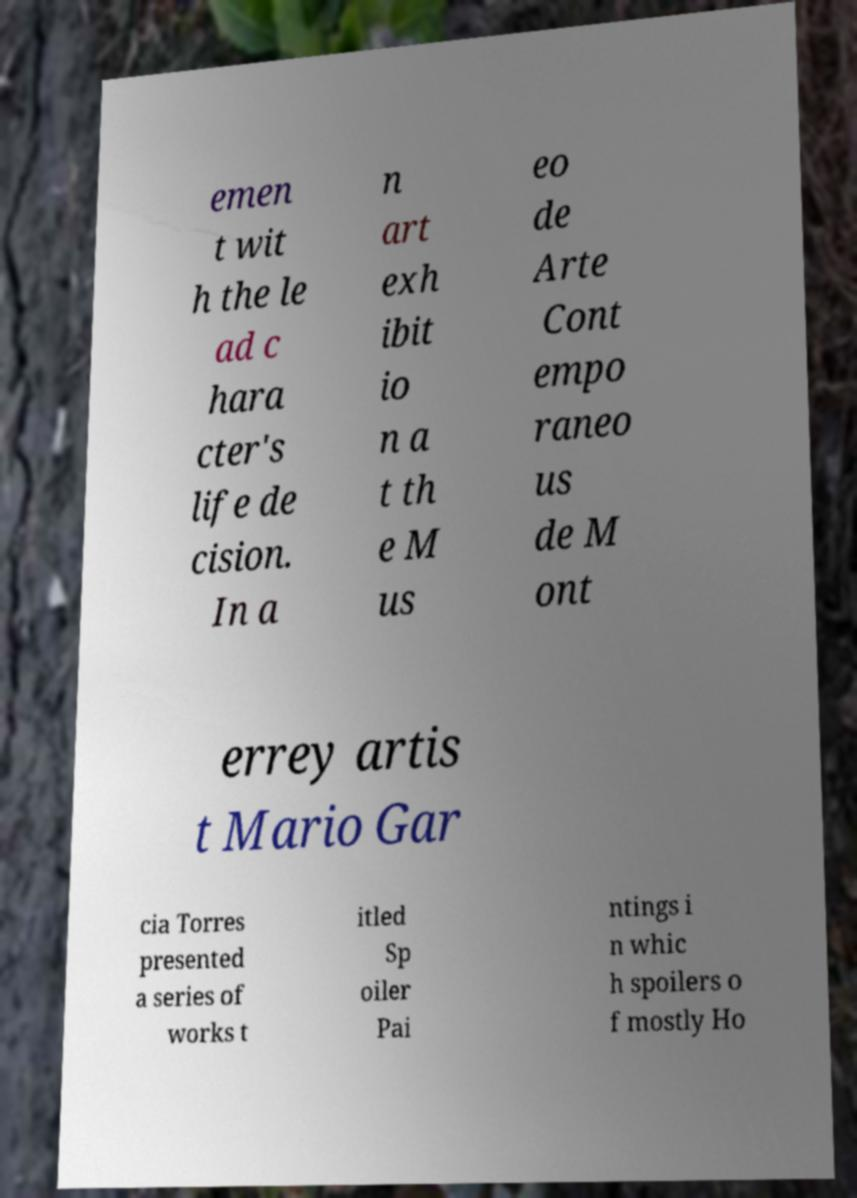What messages or text are displayed in this image? I need them in a readable, typed format. emen t wit h the le ad c hara cter's life de cision. In a n art exh ibit io n a t th e M us eo de Arte Cont empo raneo us de M ont errey artis t Mario Gar cia Torres presented a series of works t itled Sp oiler Pai ntings i n whic h spoilers o f mostly Ho 